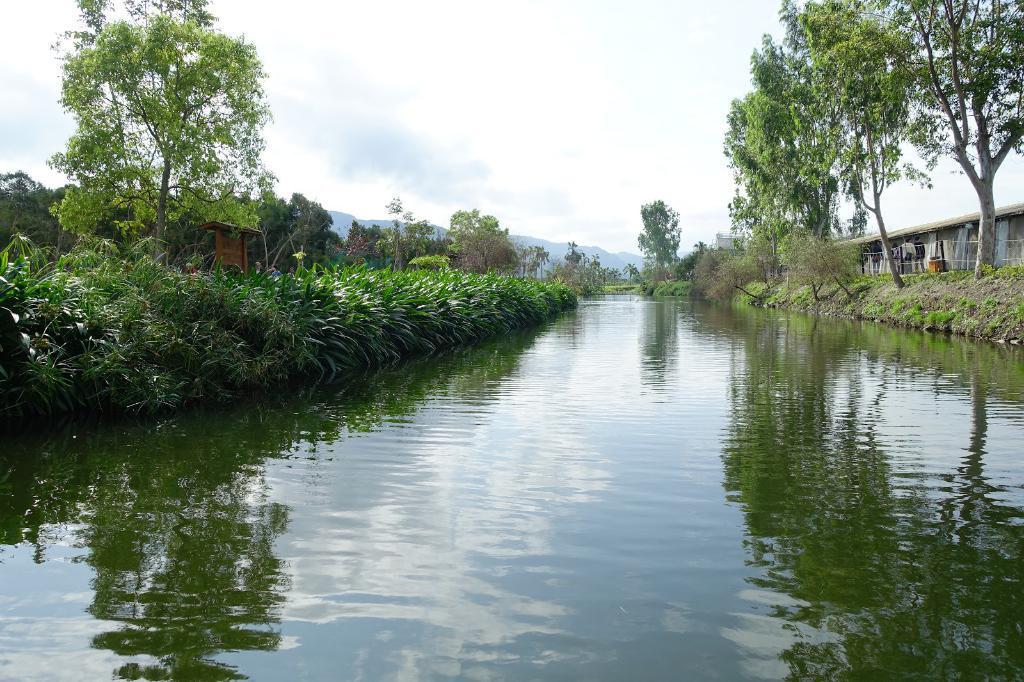Describe this image in one or two sentences. In this image we can see water in the middle of the image, on the right side of the image there are trees and a building, on the left side of the image there is grass and in the background there are mountains, trees and sky. 